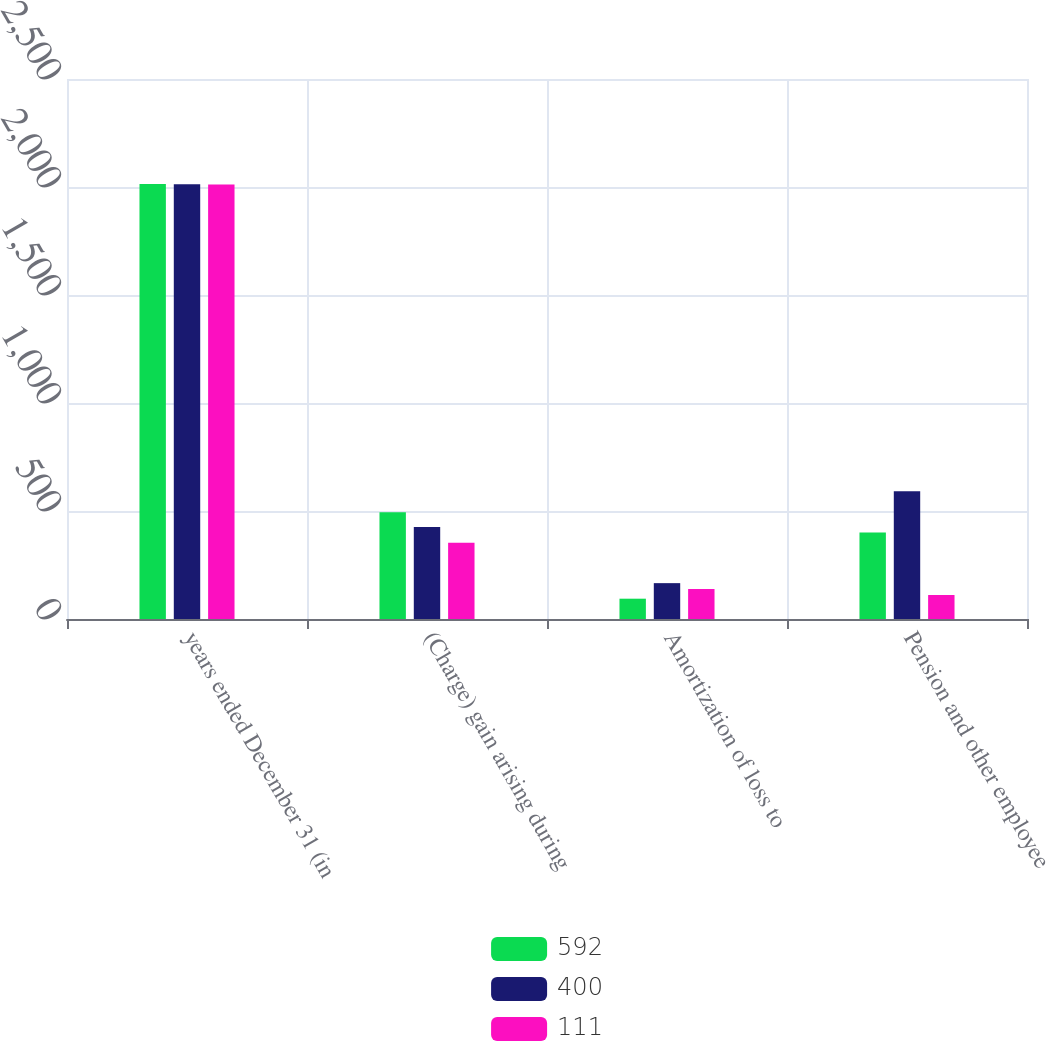<chart> <loc_0><loc_0><loc_500><loc_500><stacked_bar_chart><ecel><fcel>years ended December 31 (in<fcel>(Charge) gain arising during<fcel>Amortization of loss to<fcel>Pension and other employee<nl><fcel>592<fcel>2014<fcel>494<fcel>94<fcel>400<nl><fcel>400<fcel>2013<fcel>426<fcel>166<fcel>592<nl><fcel>111<fcel>2012<fcel>353<fcel>139<fcel>111<nl></chart> 